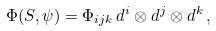<formula> <loc_0><loc_0><loc_500><loc_500>\Phi ( S , \psi ) & = \Phi _ { i j k } \, d ^ { i } \otimes d ^ { j } \otimes d ^ { k } \, ,</formula> 